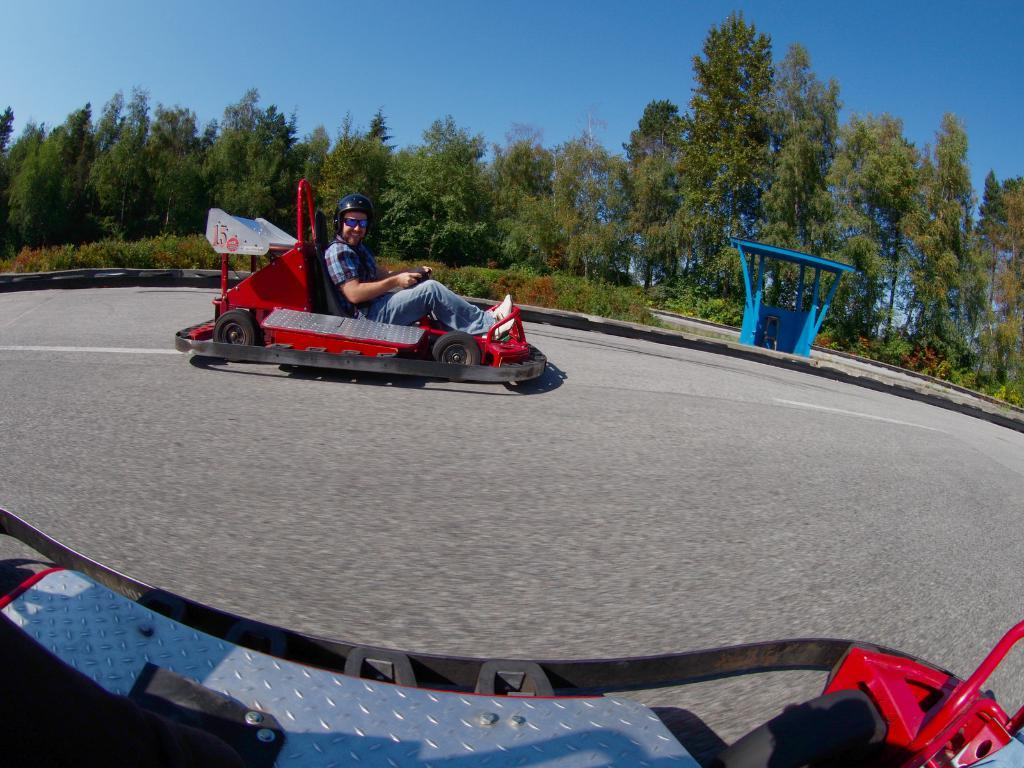What is the person in the image doing? There is a person driving a vehicle in the image. What type of natural elements can be seen in the image? There are trees and plants in the image. What type of structure is present in the image? There is a shed in the image. What part of the natural environment is visible in the image? The sky is visible in the image. What type of attraction is the person managing in the image? There is no attraction or manager present in the image; it features a person driving a vehicle and other elements such as trees, plants, a shed, and the sky. 